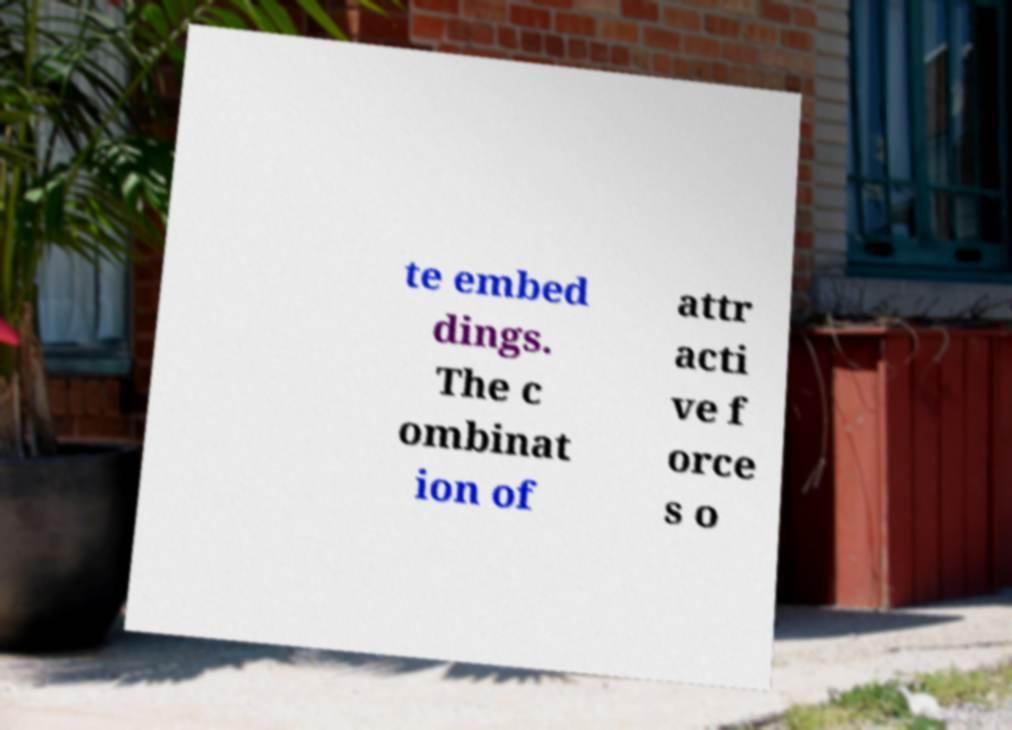Please read and relay the text visible in this image. What does it say? te embed dings. The c ombinat ion of attr acti ve f orce s o 